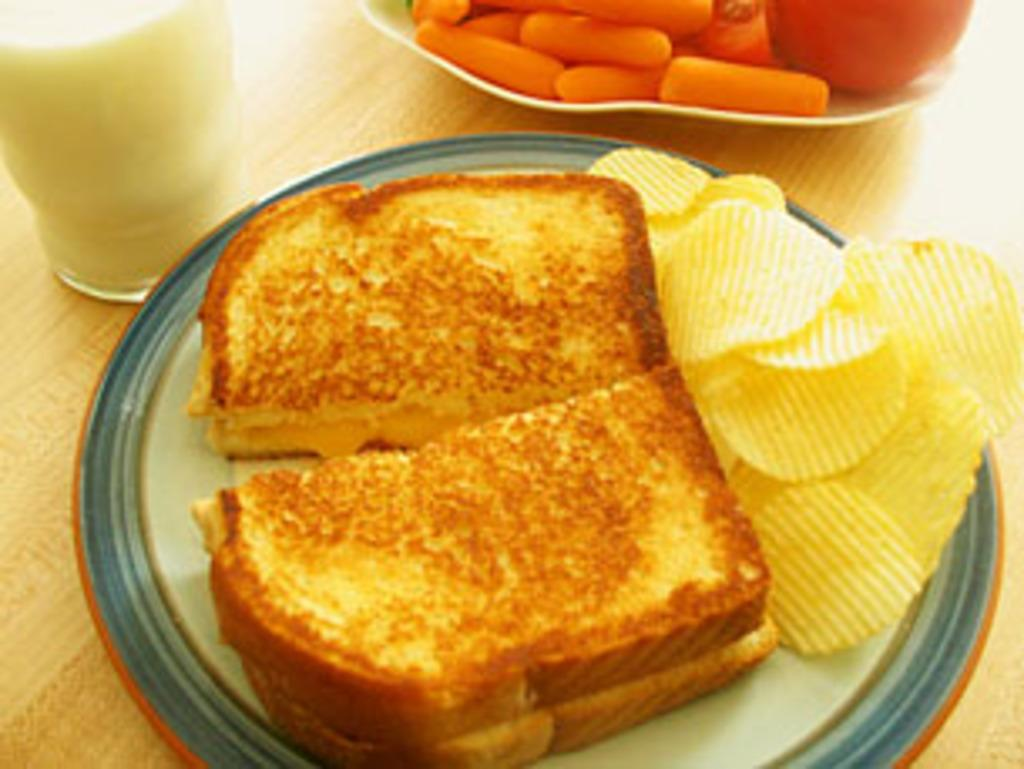What piece of furniture is present in the image? There is a table in the image. What is placed on the table? There is a glass of milk, a plate with bread slices and chips, and a bowl with food items on the table. What type of quicksand can be seen near the table in the image? There is no quicksand present in the image; it features a table with various food items. What type of locket is hanging from the bread slices on the plate? There is no locket present on the bread slices or anywhere else in the image. 